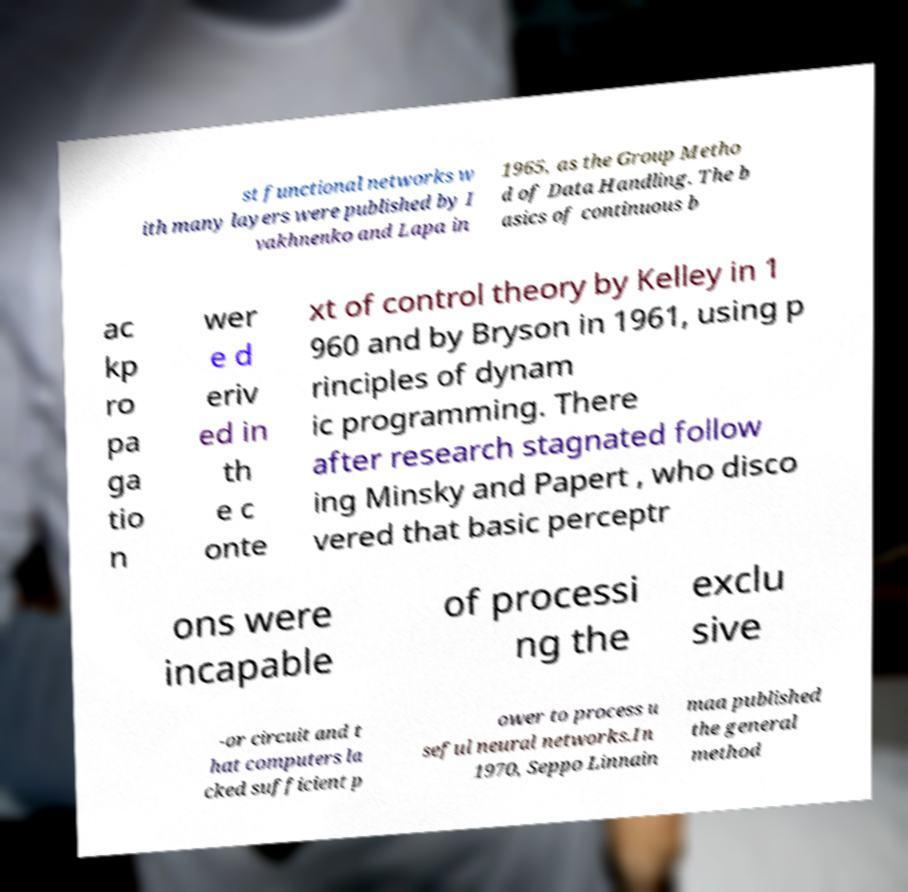Can you accurately transcribe the text from the provided image for me? st functional networks w ith many layers were published by I vakhnenko and Lapa in 1965, as the Group Metho d of Data Handling. The b asics of continuous b ac kp ro pa ga tio n wer e d eriv ed in th e c onte xt of control theory by Kelley in 1 960 and by Bryson in 1961, using p rinciples of dynam ic programming. There after research stagnated follow ing Minsky and Papert , who disco vered that basic perceptr ons were incapable of processi ng the exclu sive -or circuit and t hat computers la cked sufficient p ower to process u seful neural networks.In 1970, Seppo Linnain maa published the general method 